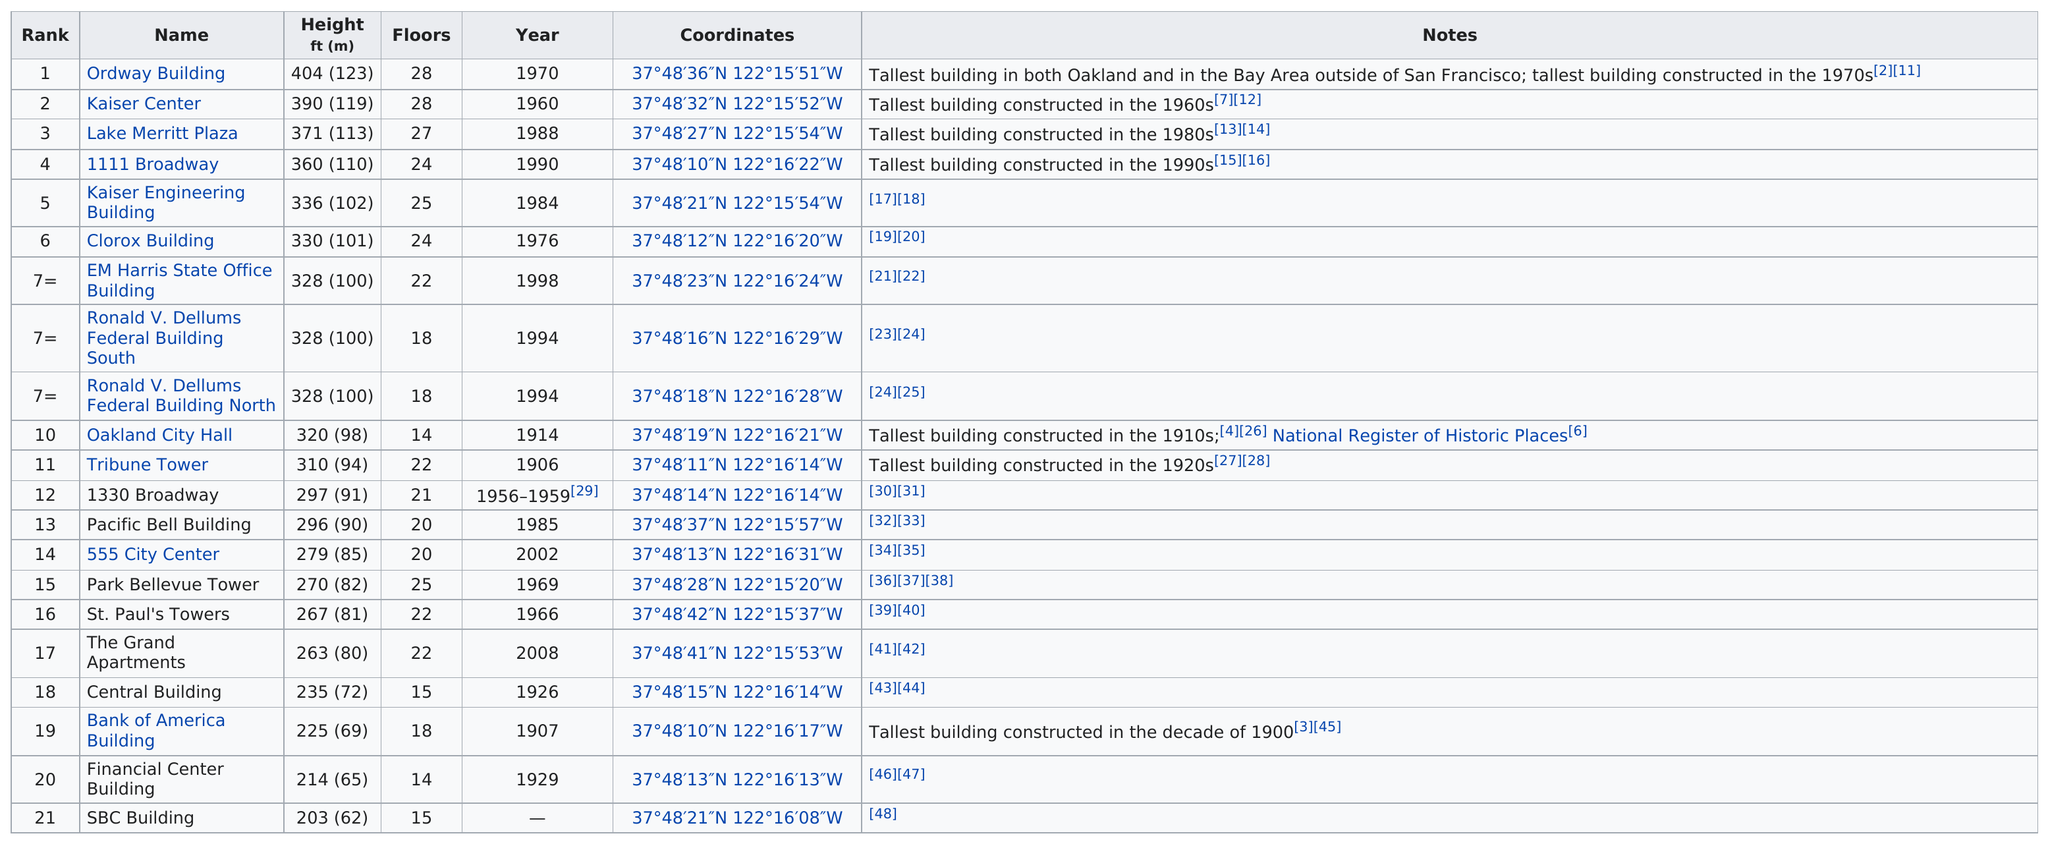Indicate a few pertinent items in this graphic. After the Ordway building, which is the tallest, comes the Kaiser Center. Of the buildings in Oakland that stand at least 200 feet tall, 12 of them have more than 20 floors. There are 21 buildings that are taller than 200 feet. Out of the tallest buildings in Oakland, 5 of them were constructed before 1950. The Ordway building has a total of 28 floors. 